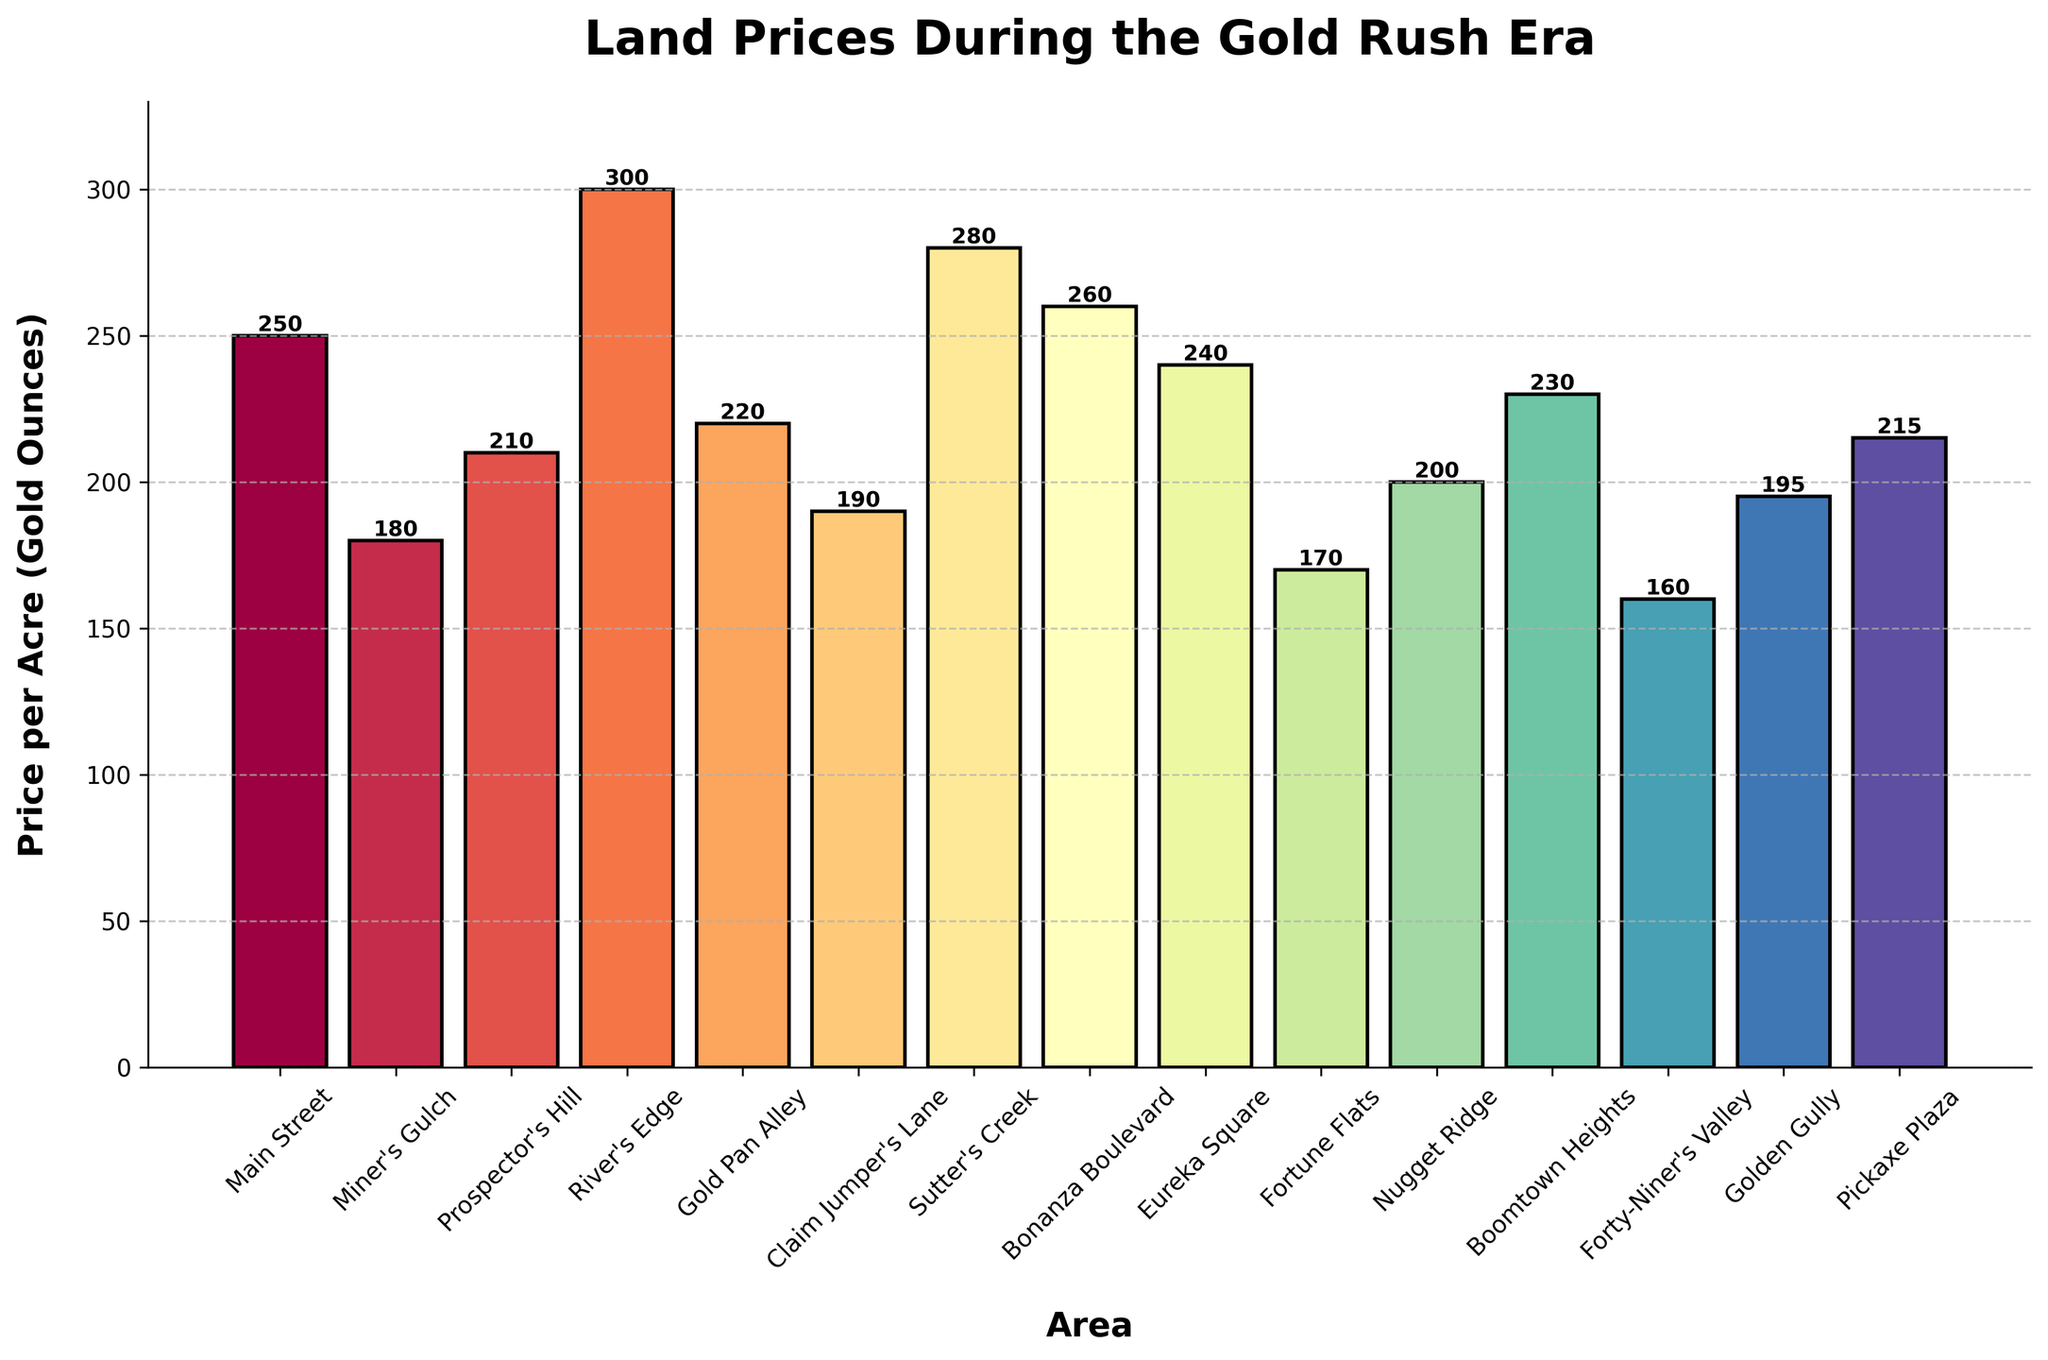Which area has the highest land price per acre? The highest bar on the chart represents the area with the highest price per acre. Observing the chart, the highest bar is labeled "River's Edge."
Answer: River's Edge Which area has the lowest land price per acre? The lowest bar on the chart represents the area with the lowest price per acre. Observing the chart, the lowest bar is labeled "Forty-Niner's Valley."
Answer: Forty-Niner's Valley What is the average price per acre across all areas? Add all the prices together and divide by the number of areas: (250 + 180 + 210 + 300 + 220 + 190 + 280 + 260 + 240 + 170 + 200 + 230 + 160 + 195 + 215) / 15 = 2950 / 15 = 196.67
Answer: 196.67 Which area has a land price per acre that is closest to the average price? The average price is approximately 196.67. Comparing each area's price to find the closest, Golden Gully has 195, which is the nearest.
Answer: Golden Gully What is the difference in land price between Main Street and Fortune Flats? Main Street has a price of 250 and Fortune Flats has 170. The difference is 250 - 170 = 80.
Answer: 80 How many areas have a price per acre greater than 220? Identify the bars higher than 220: River's Edge (300), Sutter's Creek (280), Bonanza Boulevard (260), and Boomtown Heights (230). There are 4 such bars.
Answer: 4 Which area has a price per acre 40 more than Nugget Ridge? Nugget Ridge has a price of 200. Adding 40 gives 240. Eureka Square has a price of 240.
Answer: Eureka Square What is the total price of land per acre for Miner's Gulch, Prospector's Hill, and Gold Pan Alley combined? Sum the prices of these areas: 180 (Miner's Gulch) + 210 (Prospector's Hill) + 220 (Gold Pan Alley) = 610.
Answer: 610 How does the height of the bar for Boomtown Heights compare to that of Sutter's Creek? Sutter's Creek has a price of 280 and Boomtown Heights has 230. The bar for Sutter's Creek is higher.
Answer: Sutter's Creek is higher If the bars were colored based on their height, which area would likely have the darkest color? Since darker colors often represent higher values, River's Edge, with the highest price of 300, would have the darkest color.
Answer: River's Edge 